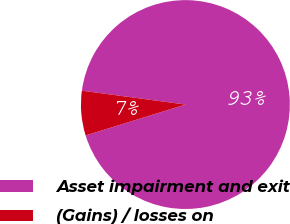Convert chart. <chart><loc_0><loc_0><loc_500><loc_500><pie_chart><fcel>Asset impairment and exit<fcel>(Gains) / losses on<nl><fcel>93.1%<fcel>6.9%<nl></chart> 